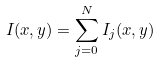<formula> <loc_0><loc_0><loc_500><loc_500>I ( x , y ) = \sum _ { j = 0 } ^ { N } I _ { j } ( x , y ) \,</formula> 